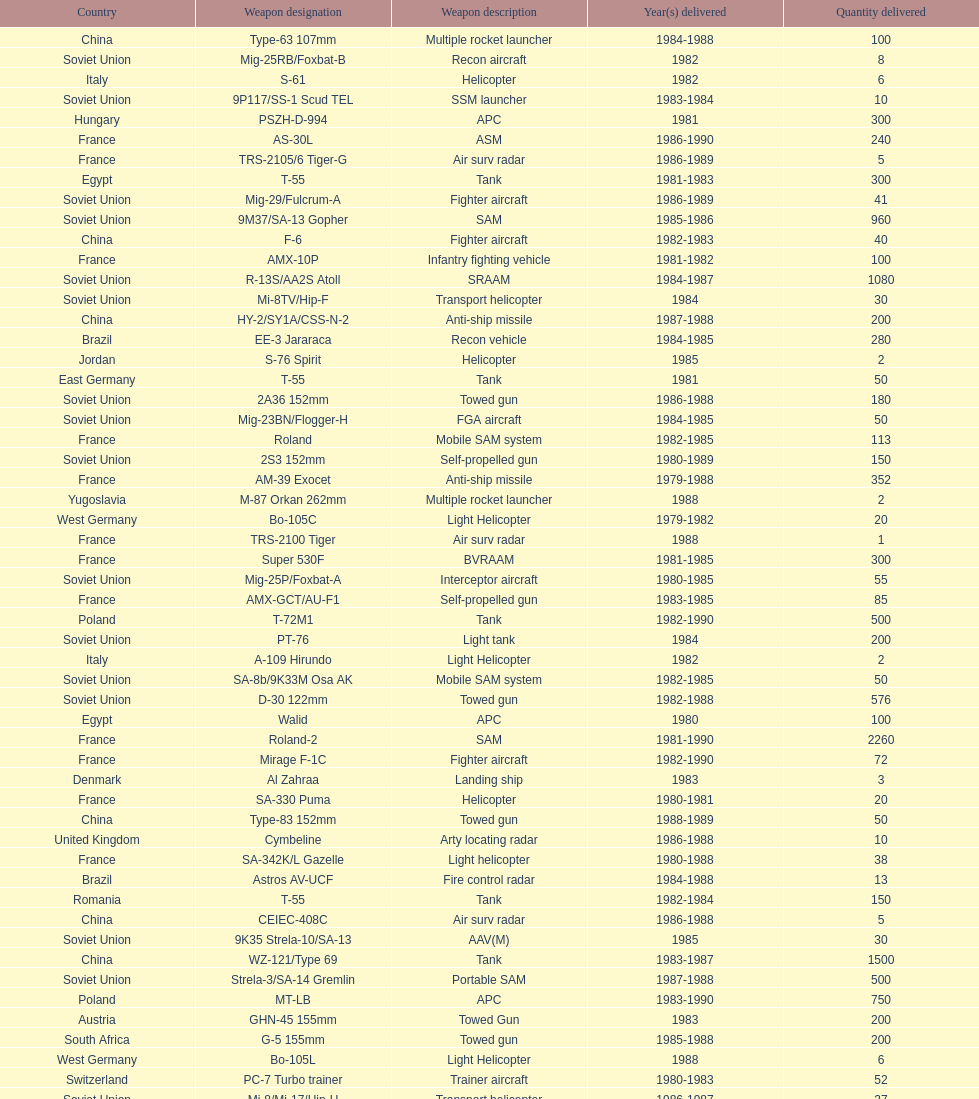According to this list, how many countries sold weapons to iraq? 21. 